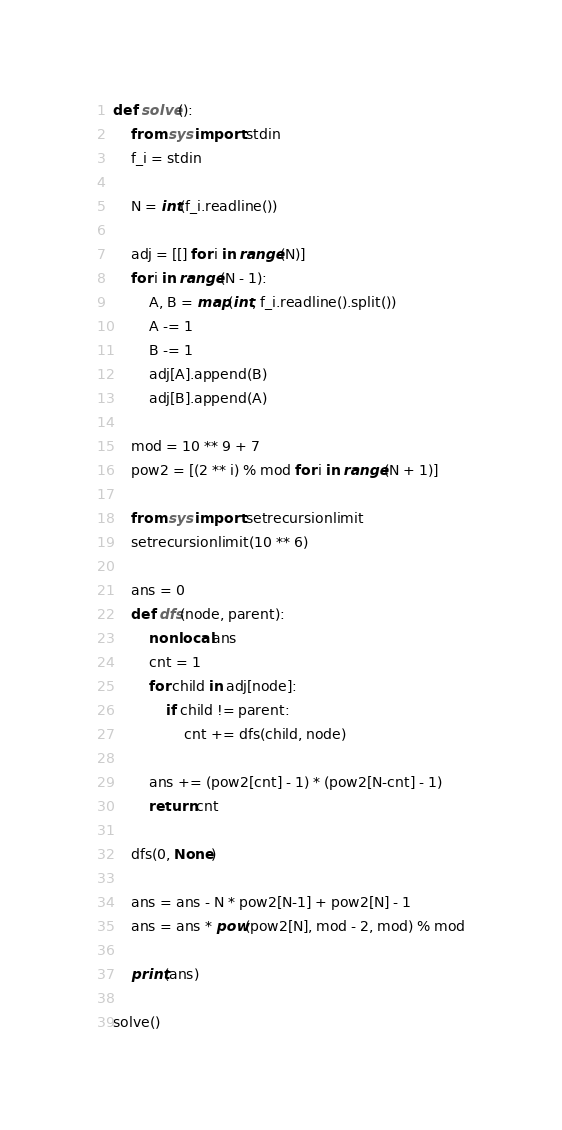<code> <loc_0><loc_0><loc_500><loc_500><_Python_>def solve():
    from sys import stdin
    f_i = stdin
    
    N = int(f_i.readline())
    
    adj = [[] for i in range(N)]
    for i in range(N - 1):
        A, B = map(int, f_i.readline().split())
        A -= 1
        B -= 1
        adj[A].append(B)
        adj[B].append(A)
    
    mod = 10 ** 9 + 7
    pow2 = [(2 ** i) % mod for i in range(N + 1)]
    
    from sys import setrecursionlimit
    setrecursionlimit(10 ** 6)
    
    ans = 0
    def dfs(node, parent):
        nonlocal ans
        cnt = 1
        for child in adj[node]:
            if child != parent:
                cnt += dfs(child, node)
        
        ans += (pow2[cnt] - 1) * (pow2[N-cnt] - 1)
        return cnt
    
    dfs(0, None)
    
    ans = ans - N * pow2[N-1] + pow2[N] - 1
    ans = ans * pow(pow2[N], mod - 2, mod) % mod
    
    print(ans)

solve()</code> 